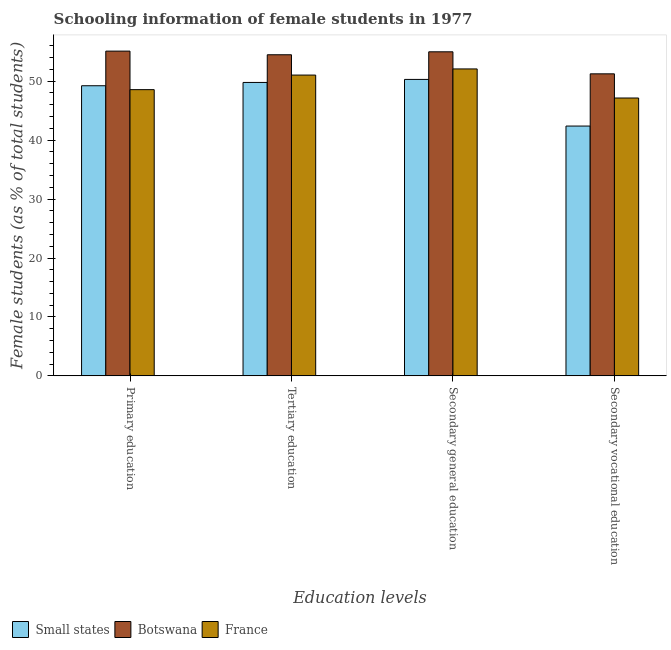How many bars are there on the 2nd tick from the left?
Ensure brevity in your answer.  3. How many bars are there on the 4th tick from the right?
Provide a succinct answer. 3. What is the percentage of female students in primary education in France?
Keep it short and to the point. 48.57. Across all countries, what is the maximum percentage of female students in tertiary education?
Offer a very short reply. 54.49. Across all countries, what is the minimum percentage of female students in secondary education?
Offer a very short reply. 50.3. In which country was the percentage of female students in tertiary education maximum?
Provide a succinct answer. Botswana. In which country was the percentage of female students in secondary vocational education minimum?
Your answer should be very brief. Small states. What is the total percentage of female students in primary education in the graph?
Provide a short and direct response. 152.9. What is the difference between the percentage of female students in primary education in France and that in Small states?
Offer a terse response. -0.66. What is the difference between the percentage of female students in tertiary education in Botswana and the percentage of female students in secondary vocational education in Small states?
Offer a very short reply. 12.1. What is the average percentage of female students in secondary vocational education per country?
Your answer should be compact. 46.93. What is the difference between the percentage of female students in secondary education and percentage of female students in secondary vocational education in Small states?
Offer a very short reply. 7.91. In how many countries, is the percentage of female students in tertiary education greater than 22 %?
Provide a short and direct response. 3. What is the ratio of the percentage of female students in secondary education in Botswana to that in France?
Offer a terse response. 1.06. What is the difference between the highest and the second highest percentage of female students in secondary education?
Make the answer very short. 2.91. What is the difference between the highest and the lowest percentage of female students in tertiary education?
Offer a terse response. 4.7. In how many countries, is the percentage of female students in primary education greater than the average percentage of female students in primary education taken over all countries?
Provide a short and direct response. 1. What does the 2nd bar from the left in Primary education represents?
Make the answer very short. Botswana. What does the 3rd bar from the right in Primary education represents?
Make the answer very short. Small states. How many bars are there?
Your answer should be compact. 12. Are the values on the major ticks of Y-axis written in scientific E-notation?
Your response must be concise. No. Does the graph contain grids?
Keep it short and to the point. No. Where does the legend appear in the graph?
Keep it short and to the point. Bottom left. How many legend labels are there?
Give a very brief answer. 3. How are the legend labels stacked?
Your answer should be compact. Horizontal. What is the title of the graph?
Your answer should be compact. Schooling information of female students in 1977. Does "Heavily indebted poor countries" appear as one of the legend labels in the graph?
Give a very brief answer. No. What is the label or title of the X-axis?
Offer a very short reply. Education levels. What is the label or title of the Y-axis?
Your response must be concise. Female students (as % of total students). What is the Female students (as % of total students) in Small states in Primary education?
Ensure brevity in your answer.  49.23. What is the Female students (as % of total students) in Botswana in Primary education?
Your answer should be very brief. 55.11. What is the Female students (as % of total students) in France in Primary education?
Make the answer very short. 48.57. What is the Female students (as % of total students) of Small states in Tertiary education?
Offer a terse response. 49.79. What is the Female students (as % of total students) in Botswana in Tertiary education?
Offer a very short reply. 54.49. What is the Female students (as % of total students) in France in Tertiary education?
Offer a terse response. 51.04. What is the Female students (as % of total students) of Small states in Secondary general education?
Offer a terse response. 50.3. What is the Female students (as % of total students) of Botswana in Secondary general education?
Make the answer very short. 54.99. What is the Female students (as % of total students) in France in Secondary general education?
Your answer should be compact. 52.08. What is the Female students (as % of total students) of Small states in Secondary vocational education?
Ensure brevity in your answer.  42.39. What is the Female students (as % of total students) of Botswana in Secondary vocational education?
Provide a succinct answer. 51.25. What is the Female students (as % of total students) in France in Secondary vocational education?
Make the answer very short. 47.15. Across all Education levels, what is the maximum Female students (as % of total students) in Small states?
Your answer should be compact. 50.3. Across all Education levels, what is the maximum Female students (as % of total students) in Botswana?
Your response must be concise. 55.11. Across all Education levels, what is the maximum Female students (as % of total students) in France?
Keep it short and to the point. 52.08. Across all Education levels, what is the minimum Female students (as % of total students) in Small states?
Make the answer very short. 42.39. Across all Education levels, what is the minimum Female students (as % of total students) in Botswana?
Offer a terse response. 51.25. Across all Education levels, what is the minimum Female students (as % of total students) in France?
Your answer should be compact. 47.15. What is the total Female students (as % of total students) in Small states in the graph?
Make the answer very short. 191.71. What is the total Female students (as % of total students) of Botswana in the graph?
Make the answer very short. 215.83. What is the total Female students (as % of total students) in France in the graph?
Keep it short and to the point. 198.84. What is the difference between the Female students (as % of total students) in Small states in Primary education and that in Tertiary education?
Offer a very short reply. -0.56. What is the difference between the Female students (as % of total students) of Botswana in Primary education and that in Tertiary education?
Give a very brief answer. 0.62. What is the difference between the Female students (as % of total students) of France in Primary education and that in Tertiary education?
Offer a terse response. -2.47. What is the difference between the Female students (as % of total students) in Small states in Primary education and that in Secondary general education?
Give a very brief answer. -1.07. What is the difference between the Female students (as % of total students) in Botswana in Primary education and that in Secondary general education?
Provide a succinct answer. 0.12. What is the difference between the Female students (as % of total students) of France in Primary education and that in Secondary general education?
Make the answer very short. -3.51. What is the difference between the Female students (as % of total students) of Small states in Primary education and that in Secondary vocational education?
Offer a terse response. 6.84. What is the difference between the Female students (as % of total students) in Botswana in Primary education and that in Secondary vocational education?
Your response must be concise. 3.86. What is the difference between the Female students (as % of total students) in France in Primary education and that in Secondary vocational education?
Your answer should be compact. 1.42. What is the difference between the Female students (as % of total students) of Small states in Tertiary education and that in Secondary general education?
Your response must be concise. -0.51. What is the difference between the Female students (as % of total students) of Botswana in Tertiary education and that in Secondary general education?
Your answer should be compact. -0.5. What is the difference between the Female students (as % of total students) of France in Tertiary education and that in Secondary general education?
Give a very brief answer. -1.04. What is the difference between the Female students (as % of total students) of Small states in Tertiary education and that in Secondary vocational education?
Your answer should be compact. 7.4. What is the difference between the Female students (as % of total students) in Botswana in Tertiary education and that in Secondary vocational education?
Keep it short and to the point. 3.24. What is the difference between the Female students (as % of total students) of France in Tertiary education and that in Secondary vocational education?
Offer a terse response. 3.89. What is the difference between the Female students (as % of total students) in Small states in Secondary general education and that in Secondary vocational education?
Your response must be concise. 7.91. What is the difference between the Female students (as % of total students) in Botswana in Secondary general education and that in Secondary vocational education?
Your response must be concise. 3.74. What is the difference between the Female students (as % of total students) in France in Secondary general education and that in Secondary vocational education?
Ensure brevity in your answer.  4.93. What is the difference between the Female students (as % of total students) in Small states in Primary education and the Female students (as % of total students) in Botswana in Tertiary education?
Your answer should be very brief. -5.26. What is the difference between the Female students (as % of total students) in Small states in Primary education and the Female students (as % of total students) in France in Tertiary education?
Give a very brief answer. -1.81. What is the difference between the Female students (as % of total students) of Botswana in Primary education and the Female students (as % of total students) of France in Tertiary education?
Provide a succinct answer. 4.06. What is the difference between the Female students (as % of total students) in Small states in Primary education and the Female students (as % of total students) in Botswana in Secondary general education?
Your answer should be very brief. -5.76. What is the difference between the Female students (as % of total students) of Small states in Primary education and the Female students (as % of total students) of France in Secondary general education?
Ensure brevity in your answer.  -2.85. What is the difference between the Female students (as % of total students) in Botswana in Primary education and the Female students (as % of total students) in France in Secondary general education?
Your answer should be very brief. 3.02. What is the difference between the Female students (as % of total students) in Small states in Primary education and the Female students (as % of total students) in Botswana in Secondary vocational education?
Offer a terse response. -2.02. What is the difference between the Female students (as % of total students) in Small states in Primary education and the Female students (as % of total students) in France in Secondary vocational education?
Make the answer very short. 2.08. What is the difference between the Female students (as % of total students) of Botswana in Primary education and the Female students (as % of total students) of France in Secondary vocational education?
Give a very brief answer. 7.96. What is the difference between the Female students (as % of total students) in Small states in Tertiary education and the Female students (as % of total students) in Botswana in Secondary general education?
Your answer should be very brief. -5.2. What is the difference between the Female students (as % of total students) in Small states in Tertiary education and the Female students (as % of total students) in France in Secondary general education?
Your answer should be compact. -2.29. What is the difference between the Female students (as % of total students) in Botswana in Tertiary education and the Female students (as % of total students) in France in Secondary general education?
Your answer should be very brief. 2.41. What is the difference between the Female students (as % of total students) of Small states in Tertiary education and the Female students (as % of total students) of Botswana in Secondary vocational education?
Your response must be concise. -1.46. What is the difference between the Female students (as % of total students) in Small states in Tertiary education and the Female students (as % of total students) in France in Secondary vocational education?
Keep it short and to the point. 2.64. What is the difference between the Female students (as % of total students) in Botswana in Tertiary education and the Female students (as % of total students) in France in Secondary vocational education?
Provide a short and direct response. 7.34. What is the difference between the Female students (as % of total students) in Small states in Secondary general education and the Female students (as % of total students) in Botswana in Secondary vocational education?
Keep it short and to the point. -0.95. What is the difference between the Female students (as % of total students) of Small states in Secondary general education and the Female students (as % of total students) of France in Secondary vocational education?
Provide a succinct answer. 3.15. What is the difference between the Female students (as % of total students) of Botswana in Secondary general education and the Female students (as % of total students) of France in Secondary vocational education?
Offer a very short reply. 7.84. What is the average Female students (as % of total students) in Small states per Education levels?
Keep it short and to the point. 47.93. What is the average Female students (as % of total students) in Botswana per Education levels?
Offer a terse response. 53.96. What is the average Female students (as % of total students) of France per Education levels?
Provide a short and direct response. 49.71. What is the difference between the Female students (as % of total students) in Small states and Female students (as % of total students) in Botswana in Primary education?
Offer a very short reply. -5.88. What is the difference between the Female students (as % of total students) of Small states and Female students (as % of total students) of France in Primary education?
Provide a succinct answer. 0.66. What is the difference between the Female students (as % of total students) of Botswana and Female students (as % of total students) of France in Primary education?
Provide a short and direct response. 6.54. What is the difference between the Female students (as % of total students) of Small states and Female students (as % of total students) of Botswana in Tertiary education?
Your answer should be very brief. -4.7. What is the difference between the Female students (as % of total students) in Small states and Female students (as % of total students) in France in Tertiary education?
Your answer should be compact. -1.25. What is the difference between the Female students (as % of total students) in Botswana and Female students (as % of total students) in France in Tertiary education?
Offer a terse response. 3.45. What is the difference between the Female students (as % of total students) in Small states and Female students (as % of total students) in Botswana in Secondary general education?
Offer a terse response. -4.69. What is the difference between the Female students (as % of total students) in Small states and Female students (as % of total students) in France in Secondary general education?
Ensure brevity in your answer.  -1.78. What is the difference between the Female students (as % of total students) of Botswana and Female students (as % of total students) of France in Secondary general education?
Provide a succinct answer. 2.91. What is the difference between the Female students (as % of total students) of Small states and Female students (as % of total students) of Botswana in Secondary vocational education?
Your response must be concise. -8.86. What is the difference between the Female students (as % of total students) of Small states and Female students (as % of total students) of France in Secondary vocational education?
Ensure brevity in your answer.  -4.76. What is the difference between the Female students (as % of total students) of Botswana and Female students (as % of total students) of France in Secondary vocational education?
Keep it short and to the point. 4.1. What is the ratio of the Female students (as % of total students) of Small states in Primary education to that in Tertiary education?
Provide a short and direct response. 0.99. What is the ratio of the Female students (as % of total students) of Botswana in Primary education to that in Tertiary education?
Your response must be concise. 1.01. What is the ratio of the Female students (as % of total students) in France in Primary education to that in Tertiary education?
Offer a very short reply. 0.95. What is the ratio of the Female students (as % of total students) in Small states in Primary education to that in Secondary general education?
Ensure brevity in your answer.  0.98. What is the ratio of the Female students (as % of total students) in Botswana in Primary education to that in Secondary general education?
Provide a short and direct response. 1. What is the ratio of the Female students (as % of total students) of France in Primary education to that in Secondary general education?
Provide a succinct answer. 0.93. What is the ratio of the Female students (as % of total students) of Small states in Primary education to that in Secondary vocational education?
Make the answer very short. 1.16. What is the ratio of the Female students (as % of total students) of Botswana in Primary education to that in Secondary vocational education?
Your answer should be compact. 1.08. What is the ratio of the Female students (as % of total students) in France in Primary education to that in Secondary vocational education?
Your answer should be very brief. 1.03. What is the ratio of the Female students (as % of total students) in Small states in Tertiary education to that in Secondary general education?
Offer a terse response. 0.99. What is the ratio of the Female students (as % of total students) of Botswana in Tertiary education to that in Secondary general education?
Your response must be concise. 0.99. What is the ratio of the Female students (as % of total students) of Small states in Tertiary education to that in Secondary vocational education?
Offer a very short reply. 1.17. What is the ratio of the Female students (as % of total students) in Botswana in Tertiary education to that in Secondary vocational education?
Give a very brief answer. 1.06. What is the ratio of the Female students (as % of total students) of France in Tertiary education to that in Secondary vocational education?
Provide a succinct answer. 1.08. What is the ratio of the Female students (as % of total students) of Small states in Secondary general education to that in Secondary vocational education?
Provide a short and direct response. 1.19. What is the ratio of the Female students (as % of total students) of Botswana in Secondary general education to that in Secondary vocational education?
Your response must be concise. 1.07. What is the ratio of the Female students (as % of total students) of France in Secondary general education to that in Secondary vocational education?
Your answer should be compact. 1.1. What is the difference between the highest and the second highest Female students (as % of total students) of Small states?
Provide a succinct answer. 0.51. What is the difference between the highest and the second highest Female students (as % of total students) in Botswana?
Make the answer very short. 0.12. What is the difference between the highest and the second highest Female students (as % of total students) of France?
Your response must be concise. 1.04. What is the difference between the highest and the lowest Female students (as % of total students) in Small states?
Provide a short and direct response. 7.91. What is the difference between the highest and the lowest Female students (as % of total students) of Botswana?
Give a very brief answer. 3.86. What is the difference between the highest and the lowest Female students (as % of total students) of France?
Your answer should be very brief. 4.93. 